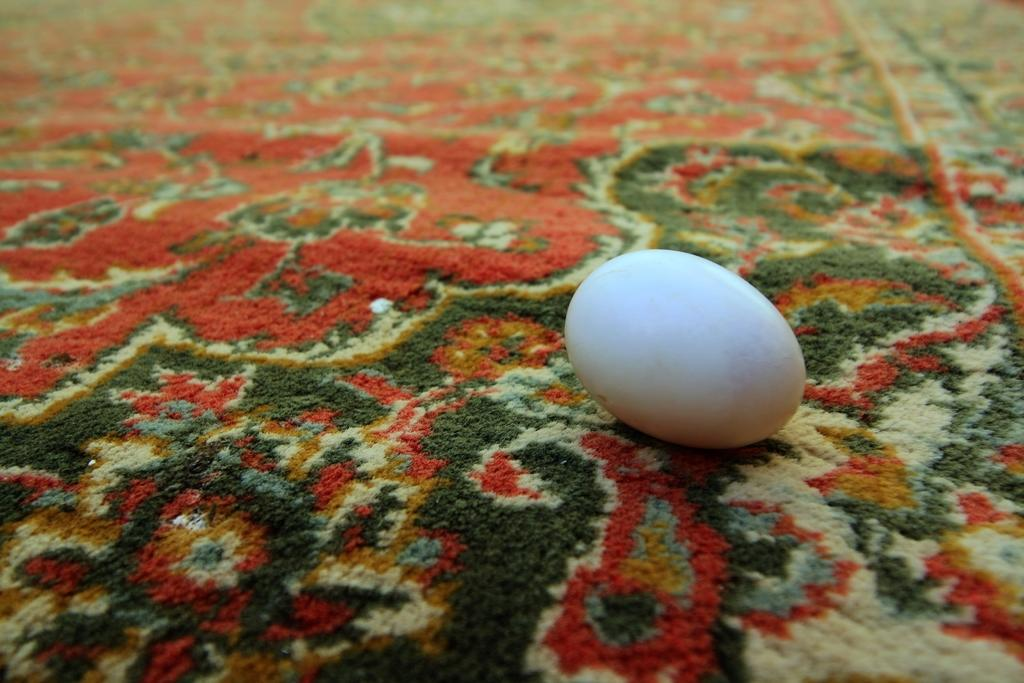What is the main object in the image? There is an egg in the image. Where is the egg located? The egg is placed on a carpet. What type of humor can be seen in the image? There is no humor present in the image; it simply features an egg on a carpet. 